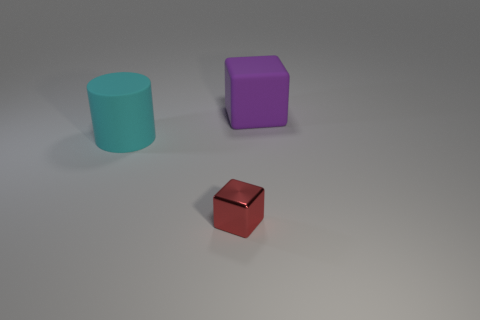Add 1 large purple rubber cubes. How many objects exist? 4 Subtract all blocks. How many objects are left? 1 Subtract 0 blue cubes. How many objects are left? 3 Subtract all red metal objects. Subtract all red metal things. How many objects are left? 1 Add 2 large cyan matte cylinders. How many large cyan matte cylinders are left? 3 Add 3 big cyan matte things. How many big cyan matte things exist? 4 